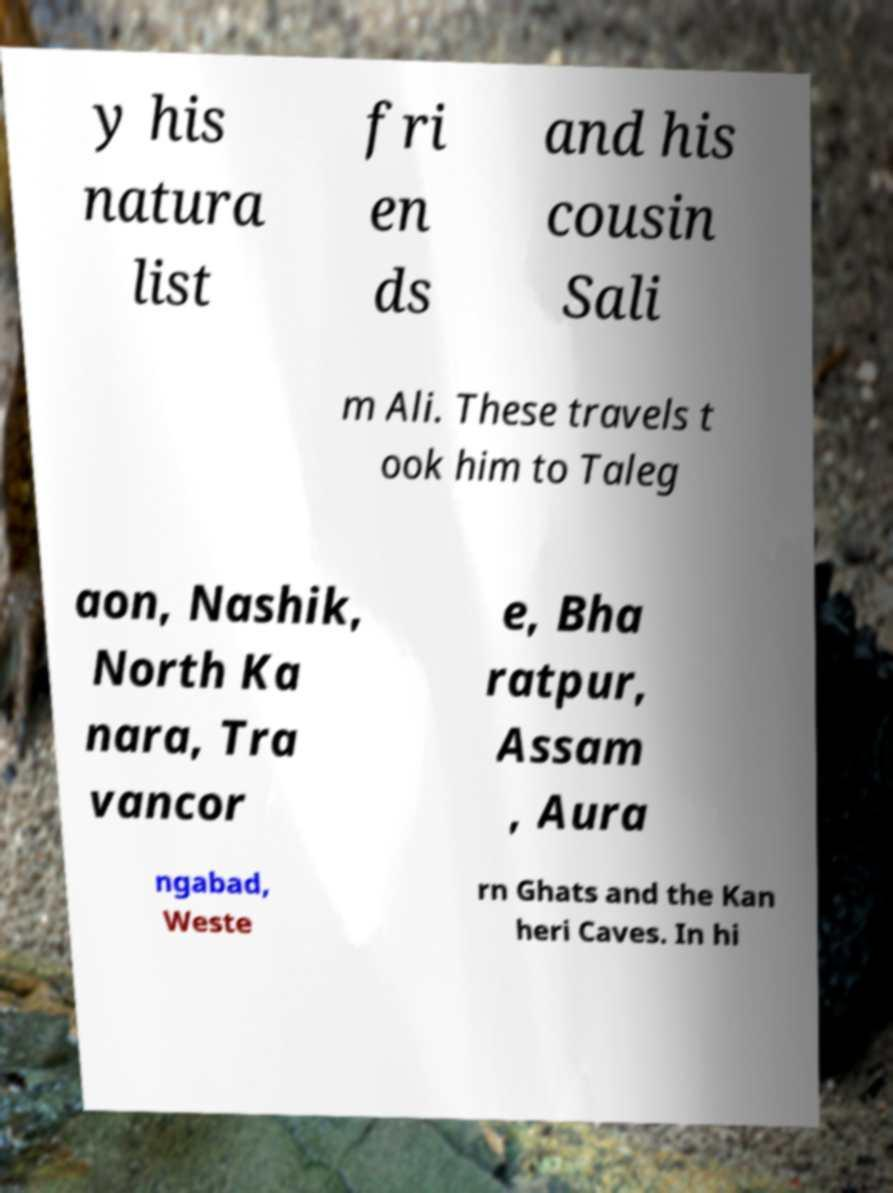There's text embedded in this image that I need extracted. Can you transcribe it verbatim? y his natura list fri en ds and his cousin Sali m Ali. These travels t ook him to Taleg aon, Nashik, North Ka nara, Tra vancor e, Bha ratpur, Assam , Aura ngabad, Weste rn Ghats and the Kan heri Caves. In hi 